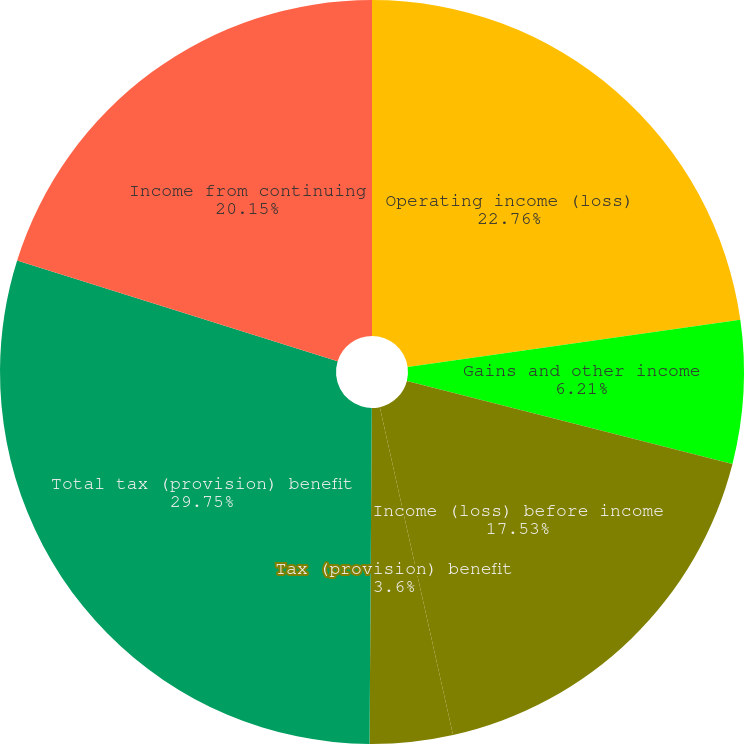Convert chart. <chart><loc_0><loc_0><loc_500><loc_500><pie_chart><fcel>Operating income (loss)<fcel>Gains and other income<fcel>Income (loss) before income<fcel>Tax (provision) benefit<fcel>Total tax (provision) benefit<fcel>Income from continuing<nl><fcel>22.76%<fcel>6.21%<fcel>17.53%<fcel>3.6%<fcel>29.74%<fcel>20.15%<nl></chart> 